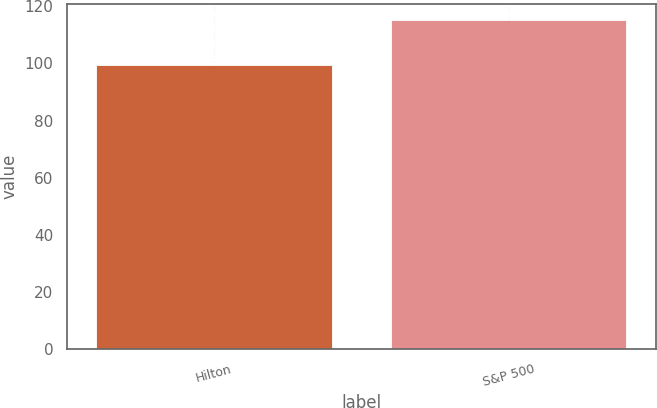<chart> <loc_0><loc_0><loc_500><loc_500><bar_chart><fcel>Hilton<fcel>S&P 500<nl><fcel>99.53<fcel>115.12<nl></chart> 